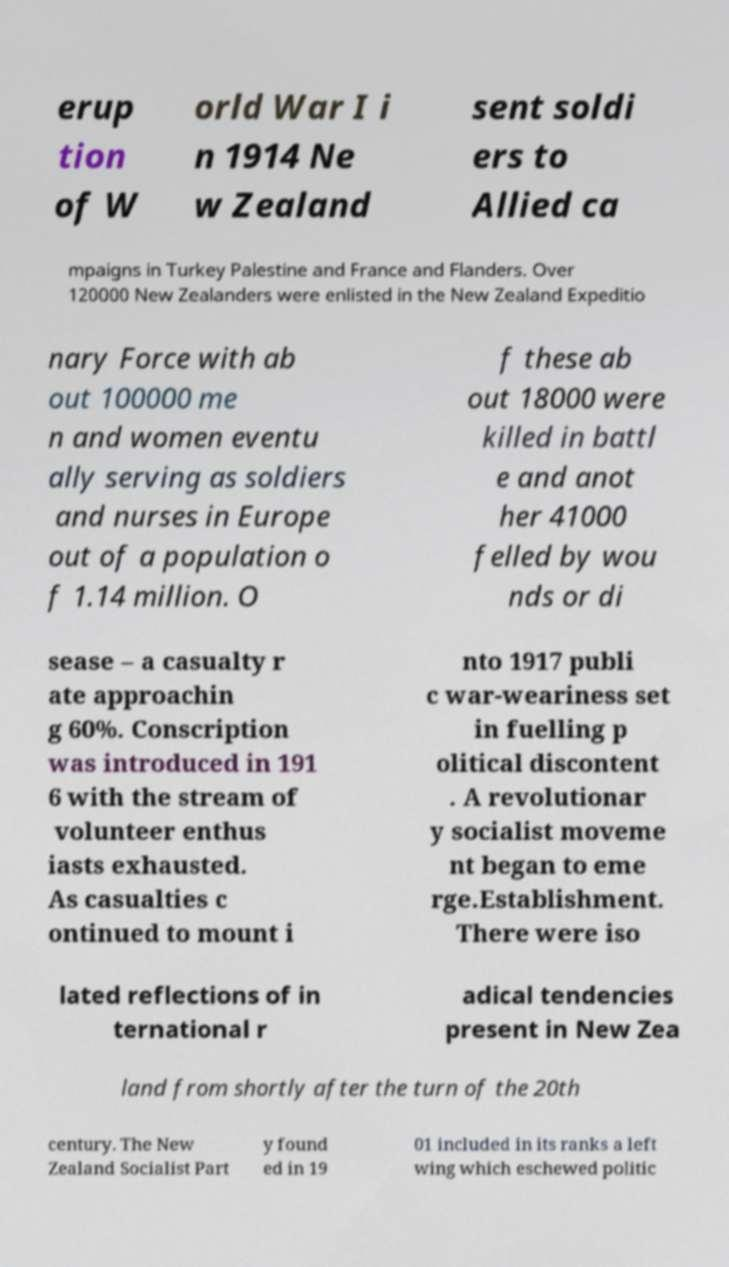Can you accurately transcribe the text from the provided image for me? erup tion of W orld War I i n 1914 Ne w Zealand sent soldi ers to Allied ca mpaigns in Turkey Palestine and France and Flanders. Over 120000 New Zealanders were enlisted in the New Zealand Expeditio nary Force with ab out 100000 me n and women eventu ally serving as soldiers and nurses in Europe out of a population o f 1.14 million. O f these ab out 18000 were killed in battl e and anot her 41000 felled by wou nds or di sease – a casualty r ate approachin g 60%. Conscription was introduced in 191 6 with the stream of volunteer enthus iasts exhausted. As casualties c ontinued to mount i nto 1917 publi c war-weariness set in fuelling p olitical discontent . A revolutionar y socialist moveme nt began to eme rge.Establishment. There were iso lated reflections of in ternational r adical tendencies present in New Zea land from shortly after the turn of the 20th century. The New Zealand Socialist Part y found ed in 19 01 included in its ranks a left wing which eschewed politic 